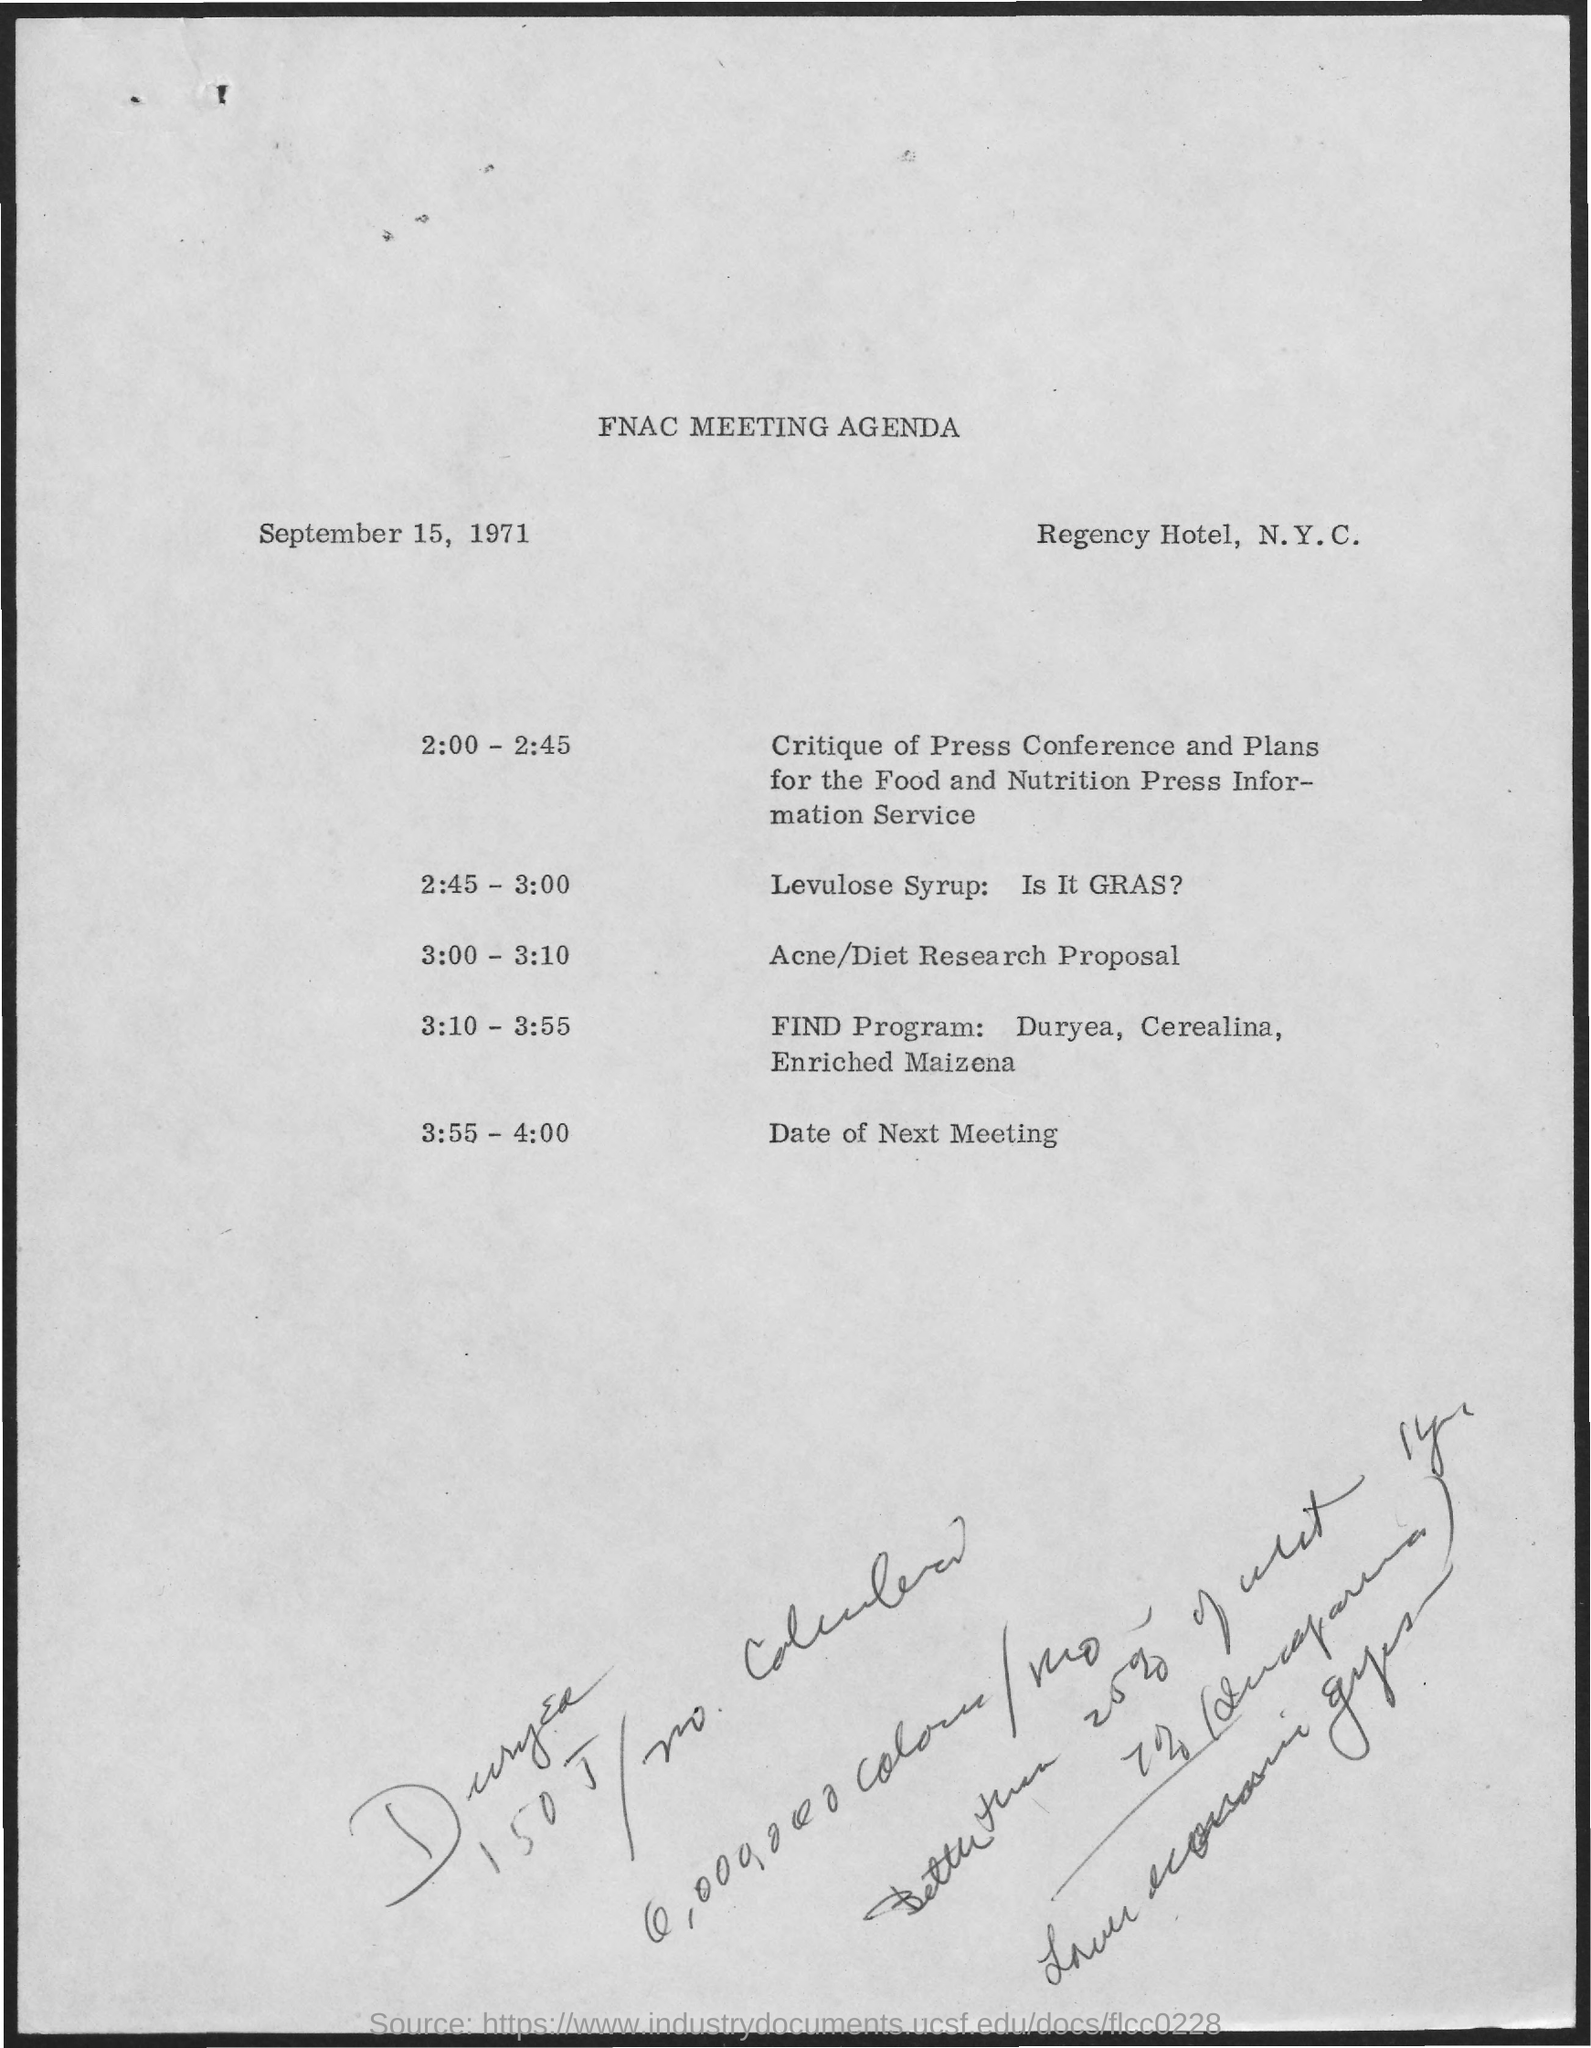Point out several critical features in this image. The final discussion in the meeting was recorded, as well as the date of the next meeting. On September 15, 1971, a meeting was held. The time at which the Acne/Diet Research proposal will be discussed is from 3:00 to 3:10. The document discusses the classification of Levulose Syrup as a Generally Recognized as Safe (GRAS) substance. The FNAC meeting is planned to take place at the Regency Hotel in New York City. 